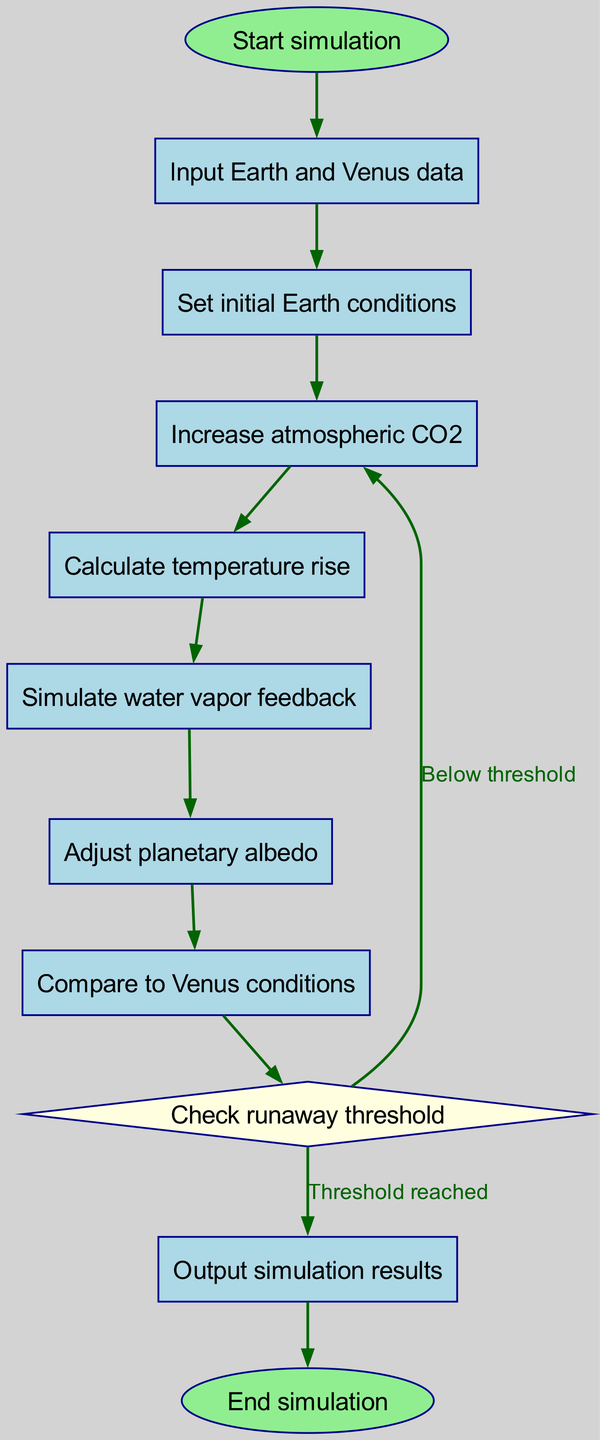What is the first step in the simulation? The first step in the simulation is identified as the node labeled "Start simulation." This is the initial point of the flowchart.
Answer: Start simulation How many nodes are in the diagram? By counting the nodes listed in the data, we see there are 11 nodes in total, representing each step in the simulation process.
Answer: 11 What happens after "Set initial Earth conditions"? The next node following "Set initial Earth conditions" is "Increase atmospheric CO2." This shows the progression from initializing conditions to modifying CO2 levels.
Answer: Increase atmospheric CO2 What type of node is "thresholdCheck"? The node "thresholdCheck" is represented as a diamond shape in the flowchart. This indicates that it is a decision-making point in the process, leading to different outcomes based on criteria met.
Answer: Diamond What is the output of the simulation if the runaway threshold is reached? If the runaway threshold is reached, the flowchart indicates that the process leads to the node labeled "Output simulation results."
Answer: Output simulation results What are the conditions for continuing the CO2 increase? The flowchart indicates that if the threshold is not reached, the process loops back to "Increase atmospheric CO2." This shows that the simulation continues adjusting CO2 levels until the threshold is achieved.
Answer: Below threshold Which node comes immediately before "Output simulation results"? The node immediately preceding "Output simulation results" is "thresholdCheck." This indicates that the results are output only after a check on whether the runaway greenhouse effect threshold has been reached.
Answer: thresholdCheck How does the flowchart adjust for planetary albedo? The flowchart shows that "Adjust planetary albedo" follows "Simulate water vapor feedback." This indicates that the effects of water vapor on climate are first simulated before adjusting the albedo to account for changes in reflectivity.
Answer: Adjust planetary albedo In total, how many edges are in the diagram? By counting the edges connecting all nodes as per the provided data, we find there are 10 edges, indicating the flow between various steps in the simulation.
Answer: 10 